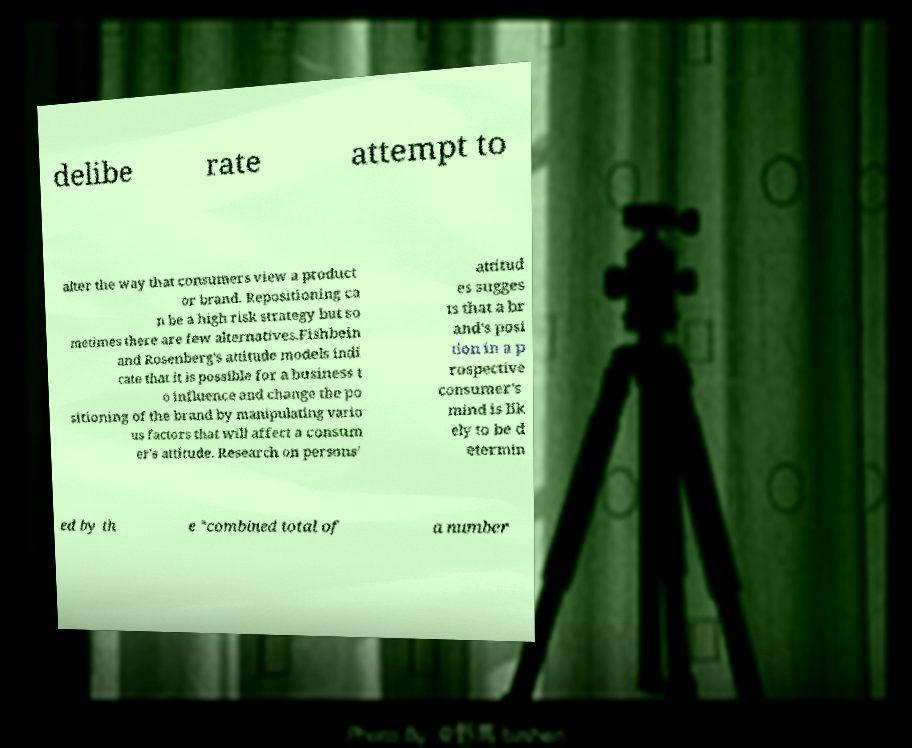There's text embedded in this image that I need extracted. Can you transcribe it verbatim? delibe rate attempt to alter the way that consumers view a product or brand. Repositioning ca n be a high risk strategy but so metimes there are few alternatives.Fishbein and Rosenberg's attitude models indi cate that it is possible for a business t o influence and change the po sitioning of the brand by manipulating vario us factors that will affect a consum er's attitude. Research on persons' attitud es sugges ts that a br and's posi tion in a p rospective consumer's mind is lik ely to be d etermin ed by th e "combined total of a number 